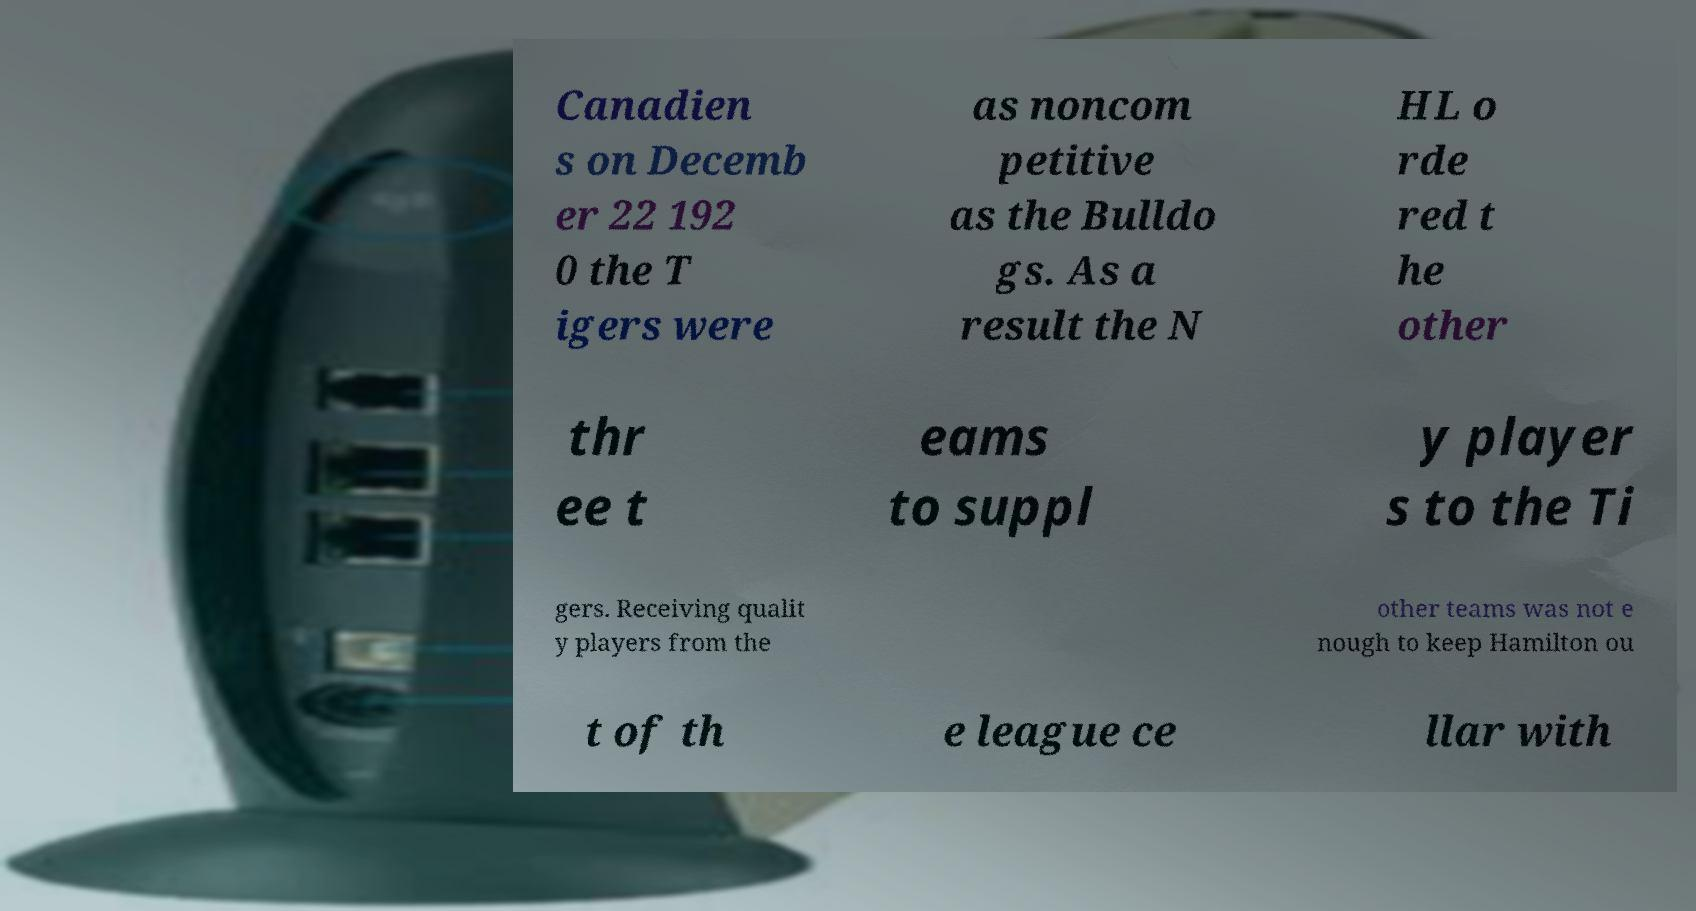What messages or text are displayed in this image? I need them in a readable, typed format. Canadien s on Decemb er 22 192 0 the T igers were as noncom petitive as the Bulldo gs. As a result the N HL o rde red t he other thr ee t eams to suppl y player s to the Ti gers. Receiving qualit y players from the other teams was not e nough to keep Hamilton ou t of th e league ce llar with 